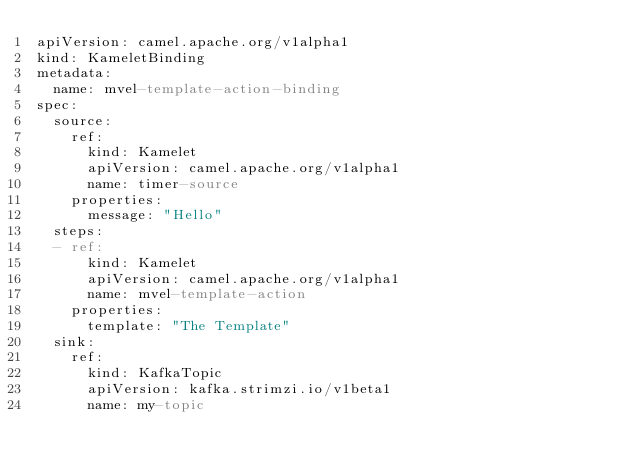<code> <loc_0><loc_0><loc_500><loc_500><_YAML_>apiVersion: camel.apache.org/v1alpha1
kind: KameletBinding
metadata:
  name: mvel-template-action-binding
spec:
  source:
    ref:
      kind: Kamelet
      apiVersion: camel.apache.org/v1alpha1
      name: timer-source
    properties:
      message: "Hello"
  steps:
  - ref:
      kind: Kamelet
      apiVersion: camel.apache.org/v1alpha1
      name: mvel-template-action
    properties:
      template: "The Template"
  sink:
    ref:
      kind: KafkaTopic
      apiVersion: kafka.strimzi.io/v1beta1
      name: my-topic
</code> 